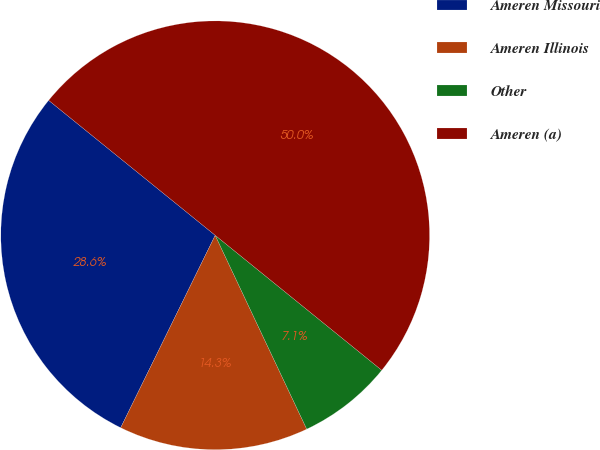<chart> <loc_0><loc_0><loc_500><loc_500><pie_chart><fcel>Ameren Missouri<fcel>Ameren Illinois<fcel>Other<fcel>Ameren (a)<nl><fcel>28.57%<fcel>14.29%<fcel>7.14%<fcel>50.0%<nl></chart> 